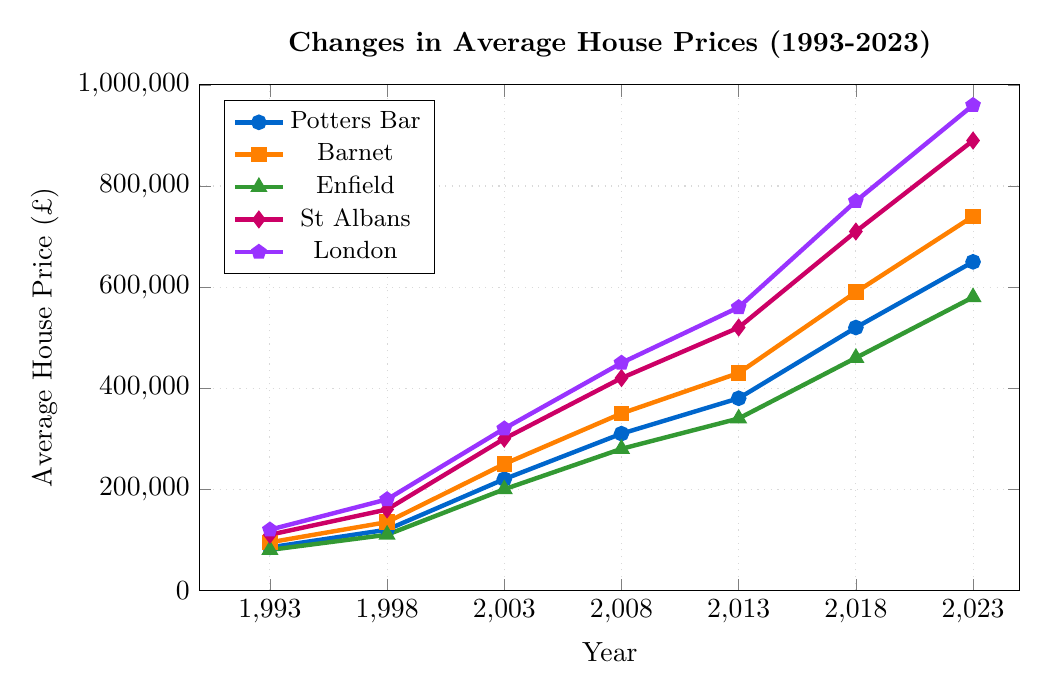What was the average house price in Potters Bar in 1993? The figure shows the average house price in Potters Bar in 1993, which is depicted by the point corresponding to Potters Bar on the Y-axis at the position of 1993 on the X-axis.
Answer: £85,000 How did the average house price in Barnet change from 2013 to 2023? To find the change in average house price, we subtract the value in 2013 from the value in 2023. From the figure, Barnet's prices were £430,000 in 2013 and £740,000 in 2023. So, the change is £740,000 - £430,000.
Answer: £310,000 Which town had the highest average house price in 2018? By comparing the heights of the points for each town in 2018 on the Y-axis, it is clear that London had the highest average house price.
Answer: London What is the percentage increase in average house prices in Potters Bar from 1993 to 2023? Calculate the percentage increase using the formula: [(new value - old value) / old value] * 100. For Potters Bar, the values are £650,000 in 2023 and £85,000 in 1993. The increase is [(£650,000 - £85,000) / £85,000] * 100.
Answer: 664.71% Between Enfield and St Albans, which had a greater increase in average house prices from 1993 to 2008? Calculate the increase for each town by subtracting the 1993 value from the 2008 value: Enfield (£280,000 - £80,000 = £200,000), St Albans (£420,000 - £110,000 = £310,000).
Answer: St Albans How do the average house prices in London in 2023 compare to those in 2008? Subtract the 2008 value from the 2023 value for London: £960,000 - £450,000.
Answer: £510,000 Which town experienced the smallest growth in average house prices between 1998 and 2003? Calculate the growth for each town by subtracting the 1998 value from the 2003 value and compare: Potters Bar (£220,000 - £120,000 = £100,000), Barnet (£250,000 - £135,000 = £115,000), Enfield (£200,000 - £110,000 = £90,000), St Albans (£300,000 - £160,000 = £140,000), London (£320,000 - £180,000 = £140,000).
Answer: Enfield In 2013, did Potters Bar have a higher or lower average house price than Enfield? By comparing the heights of the points corresponding to 2013 for both Potters Bar and Enfield, we can see Potters Bar's price (£380,000) is higher than Enfield's (£340,000).
Answer: Higher How much higher was the average house price in St Albans compared to Enfield in 2023? Subtract Enfield's value from St Albans' value for the year 2023: £890,000 - £580,000.
Answer: £310,000 What is the total growth in average house prices from 1993 to 2023 for all towns combined? Calculate the growth for each town from 1993 to 2023 and sum them up: Potters Bar (£650,000 - £85,000 = £565,000), Barnet (£740,000 - £95,000 = £645,000), Enfield (£580,000 - £80,000 = £500,000), St Albans (£890,000 - £110,000 = £780,000), London (£960,000 - £120,000 = £840,000). Total growth: £565,000 + £645,000 + £500,000 + £780,000 + £840,000.
Answer: £3,330,000 